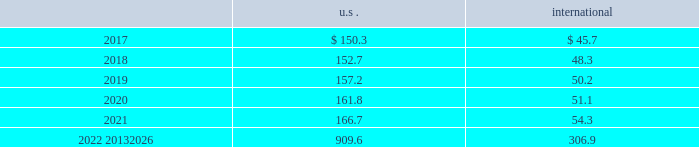Corporate and government bonds corporate and government bonds are classified as level 2 assets , as they are either valued at quoted market prices from observable pricing sources at the reporting date or valued based upon comparable securities with similar yields and credit ratings .
Real estate pooled funds real estate pooled funds are classified as level 3 assets , as they are carried at the estimated fair value of the underlying properties .
Estimated fair value is calculated utilizing a combination of key inputs , such as revenue and expense growth rates , terminal capitalization rates , and discount rates .
These key inputs are consistent with practices prevailing within the real estate investment management industry .
Other pooled funds other pooled funds classified as level 2 assets are valued at the nav of the shares held at year end , which is based on the fair value of the underlying investments .
Securities and interests classified as level 3 are carried at the estimated fair value .
The estimated fair value is based on the fair value of the underlying investment values , which includes estimated bids from brokers or other third-party vendor sources that utilize expected cash flow streams and other uncorroborated data including counterparty credit quality , default risk , discount rates , and the overall capital market liquidity .
Insurance contracts insurance contracts are classified as level 3 assets , as they are carried at contract value , which approximates the estimated fair value .
The estimated fair value is based on the fair value of the underlying investment of the insurance company .
Contributions and projected benefit payments pension contributions to funded plans and benefit payments for unfunded plans for fiscal year 2016 were $ 79.3 .
Contributions for funded plans resulted primarily from contractual and regulatory requirements .
Benefit payments to unfunded plans were due primarily to the timing of retirements and cost reduction actions .
We anticipate contributing $ 65 to $ 85 to the defined benefit pension plans in 2017 .
These contributions are anticipated to be driven primarily by contractual and regulatory requirements for funded plans and benefit payments for unfunded plans , which are dependent upon timing of retirements and actions to reorganize the business .
Projected benefit payments , which reflect expected future service , are as follows: .
These estimated benefit payments are based on assumptions about future events .
Actual benefit payments may vary significantly from these estimates .
Defined contribution plans we maintain a nonleveraged employee stock ownership plan ( esop ) which forms part of the air products and chemicals , inc .
Retirement savings plan ( rsp ) .
The esop was established in may of 2002 .
The balance of the rsp is a qualified defined contribution plan including a 401 ( k ) elective deferral component .
A substantial portion of u.s .
Employees are eligible and participate .
We treat dividends paid on esop shares as ordinary dividends .
Under existing tax law , we may deduct dividends which are paid with respect to shares held by the plan .
Shares of the company 2019s common stock in the esop totaled 3031534 as of 30 september 2016 .
Our contributions to the rsp include a company core contribution for certain eligible employees who do not receive their primary retirement benefit from the defined benefit pension plans , with the core contribution based .
Considering the year 2019 , what is the highest projected benefit payment value? 
Rationale: it is the maximum value of the projected benefit payment observed in that year .
Computations: table_max(2019, none)
Answer: 157.2. 